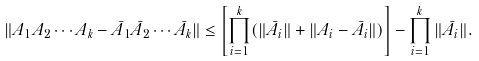Convert formula to latex. <formula><loc_0><loc_0><loc_500><loc_500>\| A _ { 1 } A _ { 2 } \cdots A _ { k } - \bar { A } _ { 1 } \bar { A } _ { 2 } \cdots \bar { A } _ { k } \| \leq \left [ \prod _ { i = 1 } ^ { k } ( \| \bar { A } _ { i } \| + \| A _ { i } - \bar { A } _ { i } \| ) \right ] - \prod _ { i = 1 } ^ { k } \| \bar { A } _ { i } \| .</formula> 